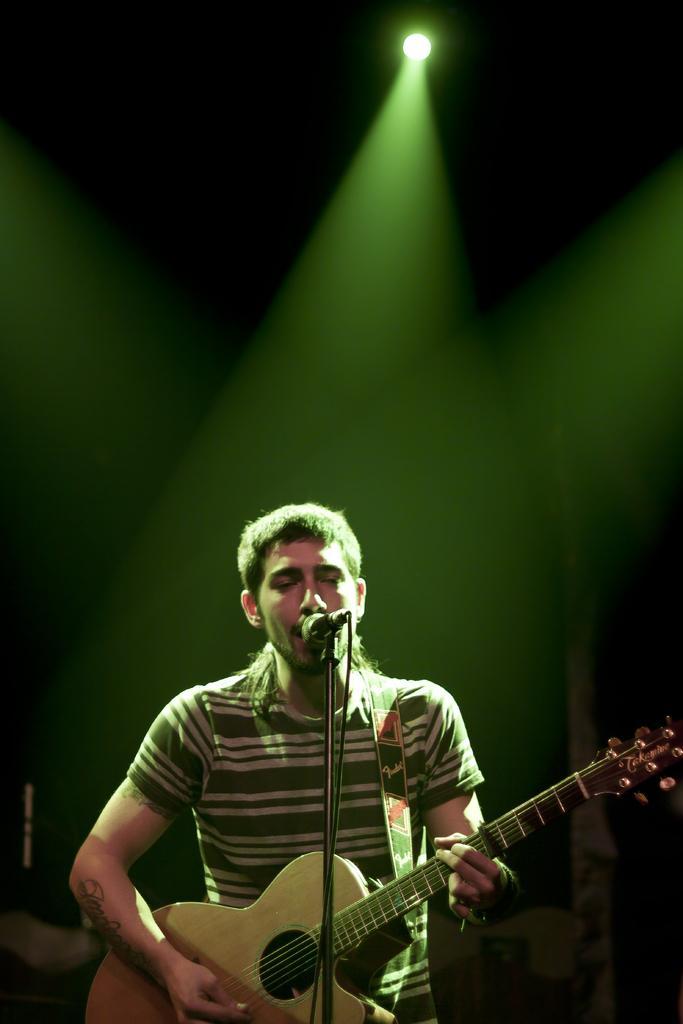Please provide a concise description of this image. This picture is clicked in the musical concert. The man in green and white T-shirt is holding a guitar in his hands. He is playing the guitar. In front of him, we see a microphone and he is singing the song on the microphone. At the top of the picture, we see a green light. 